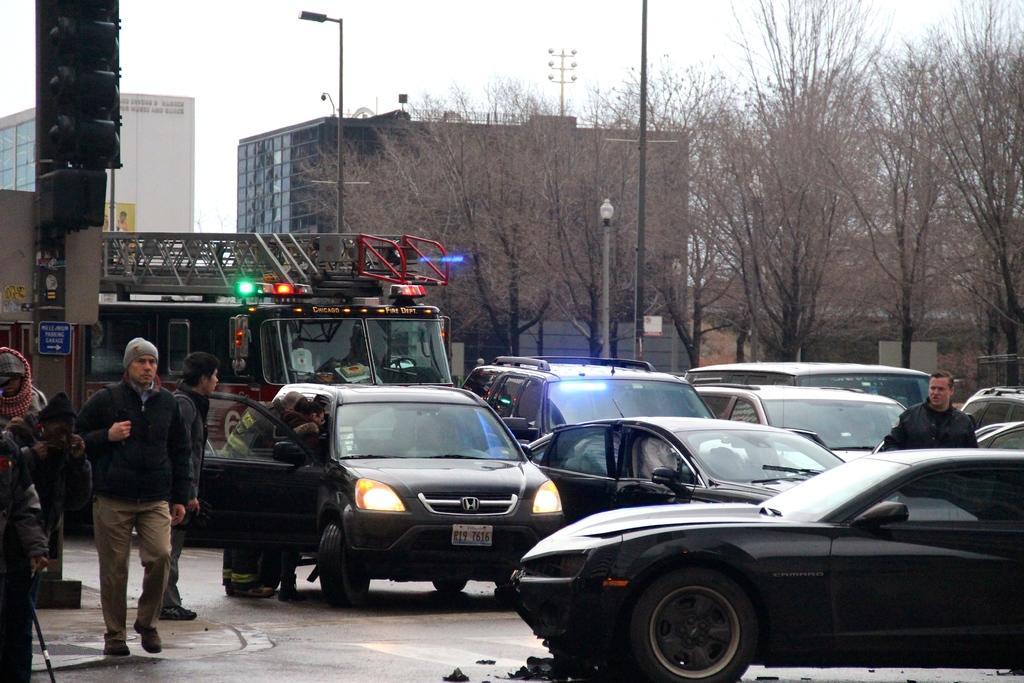Please provide a concise description of this image. In this image i can see a man walking on road at the right i can see few other cars and a man ,at the back ground i can see a vehicle, a tree, a pole and a sky. 